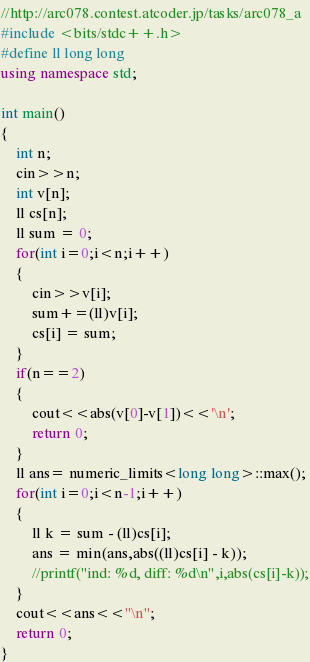Convert code to text. <code><loc_0><loc_0><loc_500><loc_500><_C++_>//http://arc078.contest.atcoder.jp/tasks/arc078_a
#include <bits/stdc++.h>
#define ll long long
using namespace std;

int main()
{
    int n;
    cin>>n;
    int v[n];
    ll cs[n];
    ll sum = 0;
    for(int i=0;i<n;i++)
    {
        cin>>v[i];
        sum+=(ll)v[i];
        cs[i] = sum;
    }
    if(n==2)
    {
        cout<<abs(v[0]-v[1])<<'\n';
        return 0;
    }
    ll ans= numeric_limits<long long>::max();
    for(int i=0;i<n-1;i++)
    {
        ll k = sum - (ll)cs[i];
        ans = min(ans,abs((ll)cs[i] - k));
        //printf("ind: %d, diff: %d\n",i,abs(cs[i]-k));
    }
    cout<<ans<<"\n";
    return 0;
}
</code> 